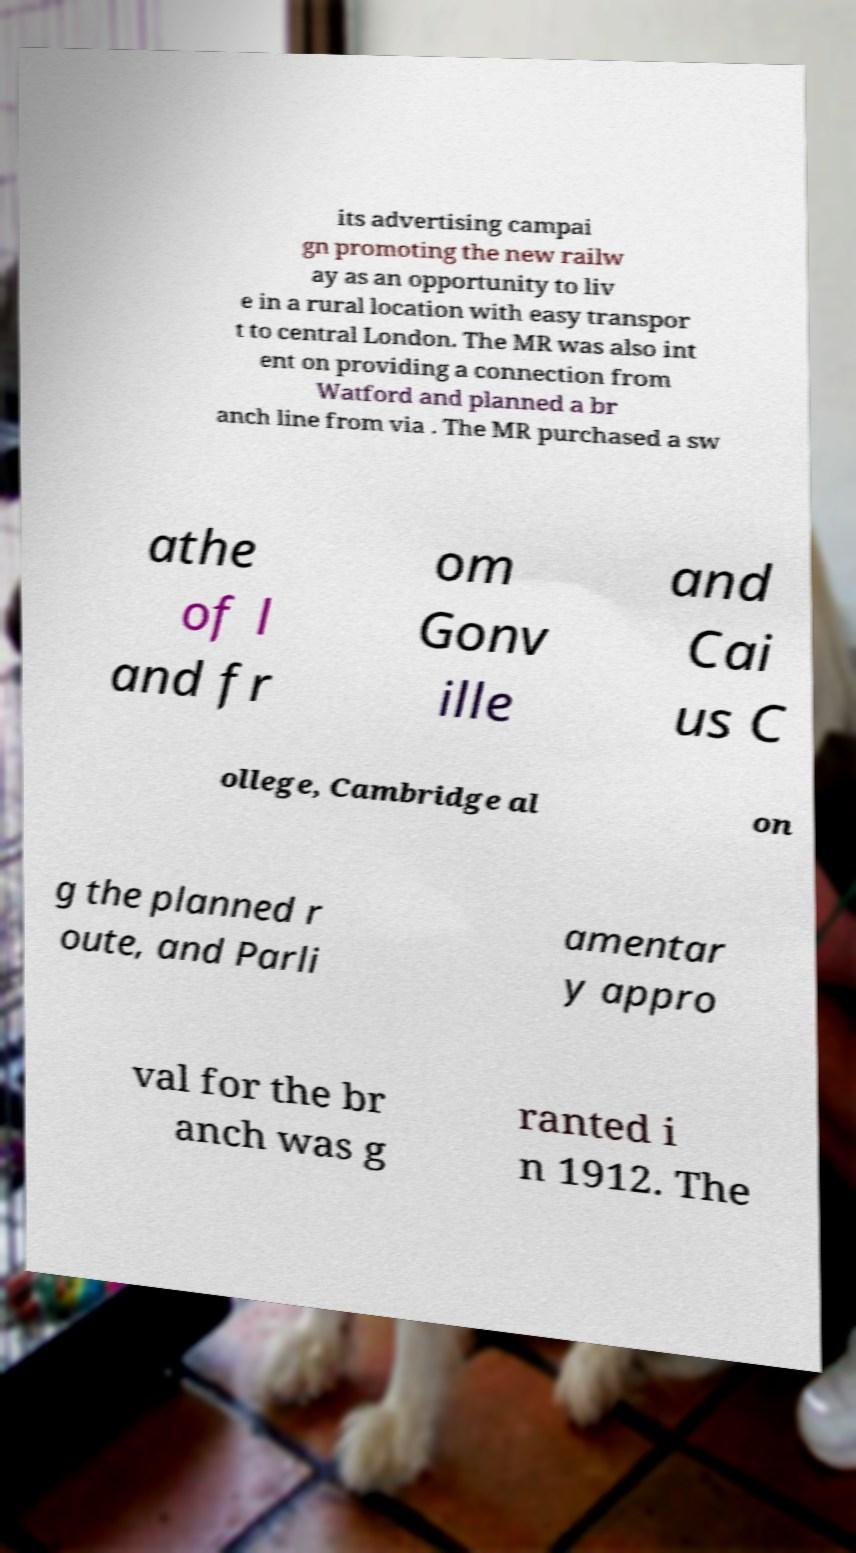There's text embedded in this image that I need extracted. Can you transcribe it verbatim? its advertising campai gn promoting the new railw ay as an opportunity to liv e in a rural location with easy transpor t to central London. The MR was also int ent on providing a connection from Watford and planned a br anch line from via . The MR purchased a sw athe of l and fr om Gonv ille and Cai us C ollege, Cambridge al on g the planned r oute, and Parli amentar y appro val for the br anch was g ranted i n 1912. The 